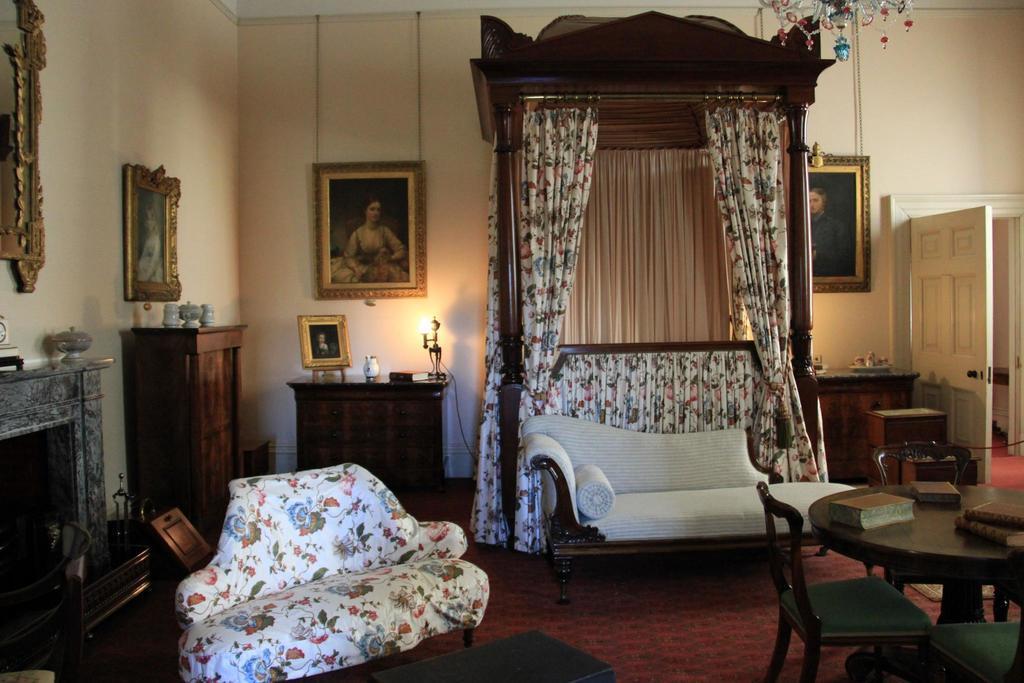In one or two sentences, can you explain what this image depicts? Here we can see a sofa,a table and a chair there are books placed on table and at the right side we can see a door and there are portraits placed on the walls and here there is a window and curtain and at the top right we can see a chandelier 